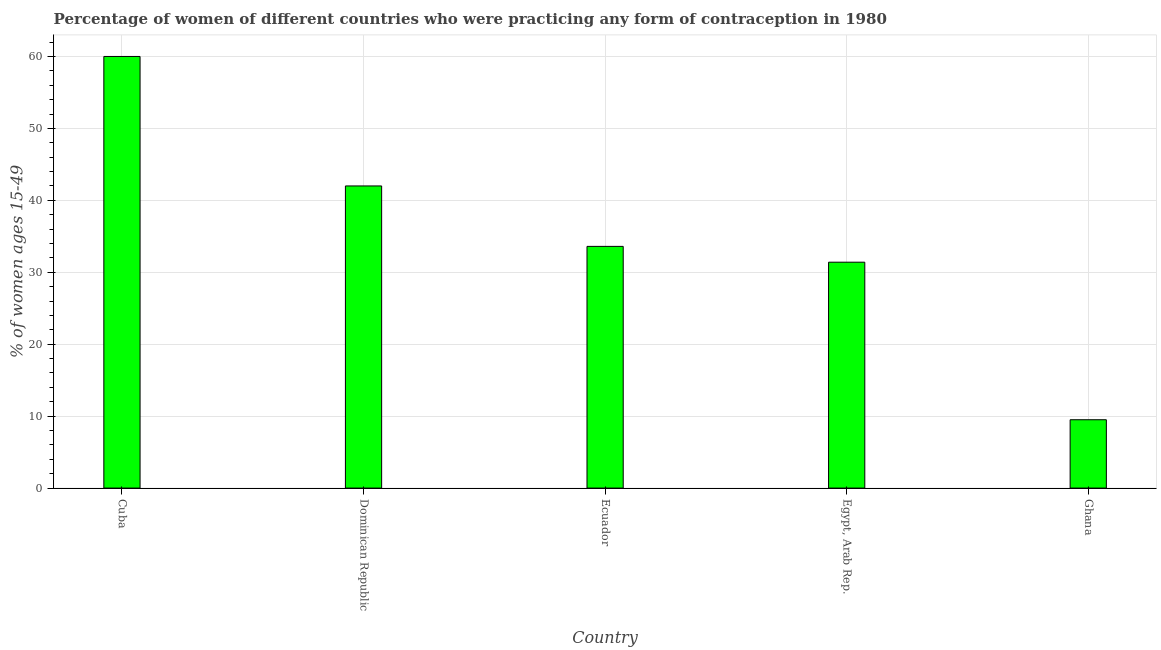Does the graph contain grids?
Offer a very short reply. Yes. What is the title of the graph?
Offer a terse response. Percentage of women of different countries who were practicing any form of contraception in 1980. What is the label or title of the Y-axis?
Make the answer very short. % of women ages 15-49. What is the contraceptive prevalence in Dominican Republic?
Keep it short and to the point. 42. In which country was the contraceptive prevalence maximum?
Keep it short and to the point. Cuba. What is the sum of the contraceptive prevalence?
Provide a succinct answer. 176.5. What is the average contraceptive prevalence per country?
Your answer should be compact. 35.3. What is the median contraceptive prevalence?
Your answer should be compact. 33.6. What is the ratio of the contraceptive prevalence in Cuba to that in Ghana?
Your answer should be compact. 6.32. Is the difference between the contraceptive prevalence in Cuba and Egypt, Arab Rep. greater than the difference between any two countries?
Ensure brevity in your answer.  No. What is the difference between the highest and the second highest contraceptive prevalence?
Offer a terse response. 18. What is the difference between the highest and the lowest contraceptive prevalence?
Offer a very short reply. 50.5. In how many countries, is the contraceptive prevalence greater than the average contraceptive prevalence taken over all countries?
Keep it short and to the point. 2. Are all the bars in the graph horizontal?
Your answer should be very brief. No. What is the difference between two consecutive major ticks on the Y-axis?
Offer a terse response. 10. What is the % of women ages 15-49 of Ecuador?
Your answer should be compact. 33.6. What is the % of women ages 15-49 of Egypt, Arab Rep.?
Offer a terse response. 31.4. What is the % of women ages 15-49 of Ghana?
Provide a succinct answer. 9.5. What is the difference between the % of women ages 15-49 in Cuba and Dominican Republic?
Provide a succinct answer. 18. What is the difference between the % of women ages 15-49 in Cuba and Ecuador?
Make the answer very short. 26.4. What is the difference between the % of women ages 15-49 in Cuba and Egypt, Arab Rep.?
Give a very brief answer. 28.6. What is the difference between the % of women ages 15-49 in Cuba and Ghana?
Keep it short and to the point. 50.5. What is the difference between the % of women ages 15-49 in Dominican Republic and Egypt, Arab Rep.?
Your answer should be very brief. 10.6. What is the difference between the % of women ages 15-49 in Dominican Republic and Ghana?
Make the answer very short. 32.5. What is the difference between the % of women ages 15-49 in Ecuador and Ghana?
Provide a short and direct response. 24.1. What is the difference between the % of women ages 15-49 in Egypt, Arab Rep. and Ghana?
Provide a succinct answer. 21.9. What is the ratio of the % of women ages 15-49 in Cuba to that in Dominican Republic?
Ensure brevity in your answer.  1.43. What is the ratio of the % of women ages 15-49 in Cuba to that in Ecuador?
Give a very brief answer. 1.79. What is the ratio of the % of women ages 15-49 in Cuba to that in Egypt, Arab Rep.?
Provide a succinct answer. 1.91. What is the ratio of the % of women ages 15-49 in Cuba to that in Ghana?
Your answer should be compact. 6.32. What is the ratio of the % of women ages 15-49 in Dominican Republic to that in Egypt, Arab Rep.?
Your response must be concise. 1.34. What is the ratio of the % of women ages 15-49 in Dominican Republic to that in Ghana?
Offer a terse response. 4.42. What is the ratio of the % of women ages 15-49 in Ecuador to that in Egypt, Arab Rep.?
Offer a very short reply. 1.07. What is the ratio of the % of women ages 15-49 in Ecuador to that in Ghana?
Offer a very short reply. 3.54. What is the ratio of the % of women ages 15-49 in Egypt, Arab Rep. to that in Ghana?
Offer a terse response. 3.31. 